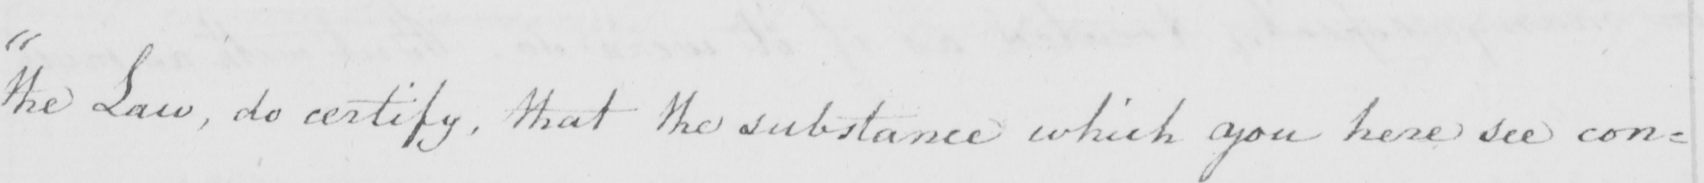What text is written in this handwritten line? " the Law , do certify , that the substance which you here see con= 